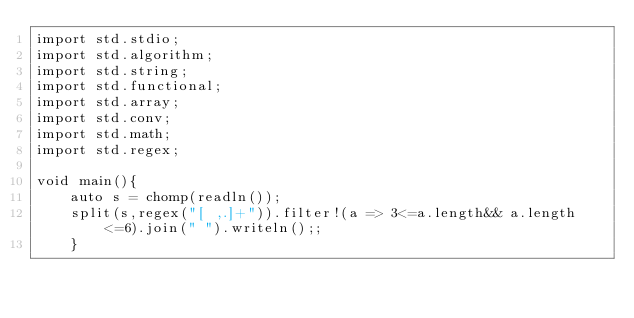<code> <loc_0><loc_0><loc_500><loc_500><_D_>import std.stdio;
import std.algorithm;
import std.string;
import std.functional;
import std.array;
import std.conv;
import std.math;
import std.regex;

void main(){
    auto s = chomp(readln());
    split(s,regex("[ ,.]+")).filter!(a => 3<=a.length&& a.length<=6).join(" ").writeln();;
    }</code> 